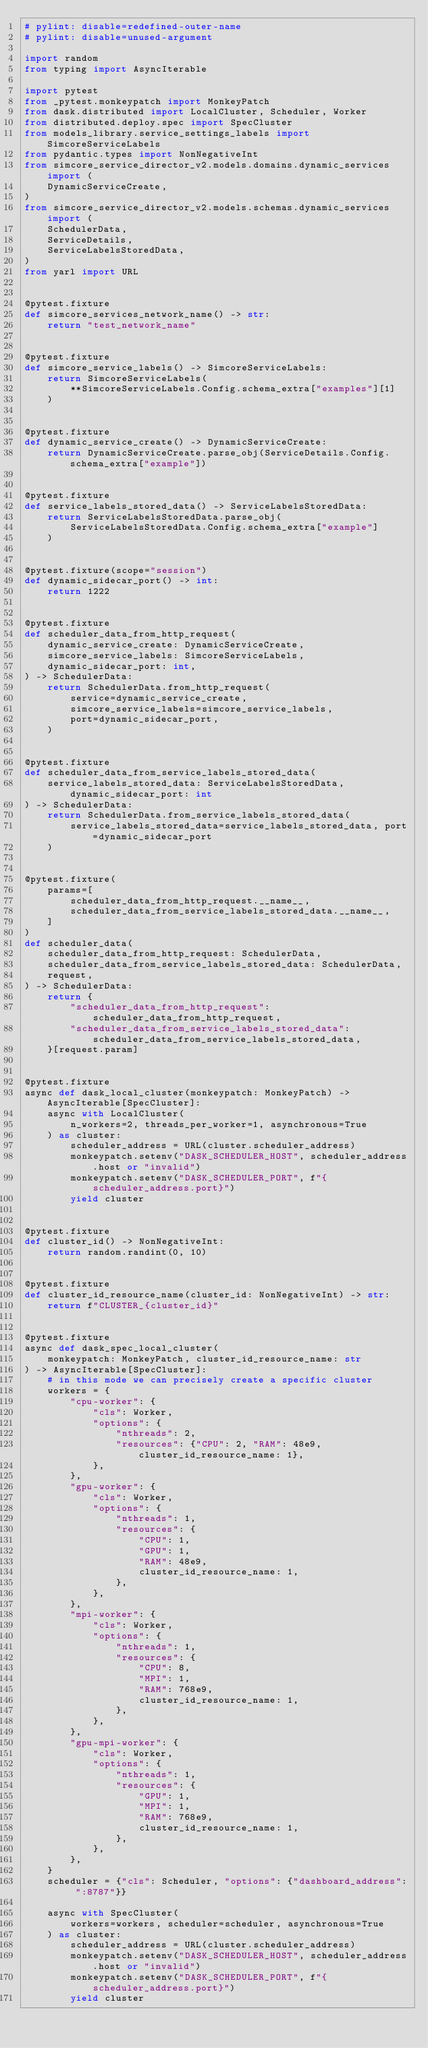<code> <loc_0><loc_0><loc_500><loc_500><_Python_># pylint: disable=redefined-outer-name
# pylint: disable=unused-argument

import random
from typing import AsyncIterable

import pytest
from _pytest.monkeypatch import MonkeyPatch
from dask.distributed import LocalCluster, Scheduler, Worker
from distributed.deploy.spec import SpecCluster
from models_library.service_settings_labels import SimcoreServiceLabels
from pydantic.types import NonNegativeInt
from simcore_service_director_v2.models.domains.dynamic_services import (
    DynamicServiceCreate,
)
from simcore_service_director_v2.models.schemas.dynamic_services import (
    SchedulerData,
    ServiceDetails,
    ServiceLabelsStoredData,
)
from yarl import URL


@pytest.fixture
def simcore_services_network_name() -> str:
    return "test_network_name"


@pytest.fixture
def simcore_service_labels() -> SimcoreServiceLabels:
    return SimcoreServiceLabels(
        **SimcoreServiceLabels.Config.schema_extra["examples"][1]
    )


@pytest.fixture
def dynamic_service_create() -> DynamicServiceCreate:
    return DynamicServiceCreate.parse_obj(ServiceDetails.Config.schema_extra["example"])


@pytest.fixture
def service_labels_stored_data() -> ServiceLabelsStoredData:
    return ServiceLabelsStoredData.parse_obj(
        ServiceLabelsStoredData.Config.schema_extra["example"]
    )


@pytest.fixture(scope="session")
def dynamic_sidecar_port() -> int:
    return 1222


@pytest.fixture
def scheduler_data_from_http_request(
    dynamic_service_create: DynamicServiceCreate,
    simcore_service_labels: SimcoreServiceLabels,
    dynamic_sidecar_port: int,
) -> SchedulerData:
    return SchedulerData.from_http_request(
        service=dynamic_service_create,
        simcore_service_labels=simcore_service_labels,
        port=dynamic_sidecar_port,
    )


@pytest.fixture
def scheduler_data_from_service_labels_stored_data(
    service_labels_stored_data: ServiceLabelsStoredData, dynamic_sidecar_port: int
) -> SchedulerData:
    return SchedulerData.from_service_labels_stored_data(
        service_labels_stored_data=service_labels_stored_data, port=dynamic_sidecar_port
    )


@pytest.fixture(
    params=[
        scheduler_data_from_http_request.__name__,
        scheduler_data_from_service_labels_stored_data.__name__,
    ]
)
def scheduler_data(
    scheduler_data_from_http_request: SchedulerData,
    scheduler_data_from_service_labels_stored_data: SchedulerData,
    request,
) -> SchedulerData:
    return {
        "scheduler_data_from_http_request": scheduler_data_from_http_request,
        "scheduler_data_from_service_labels_stored_data": scheduler_data_from_service_labels_stored_data,
    }[request.param]


@pytest.fixture
async def dask_local_cluster(monkeypatch: MonkeyPatch) -> AsyncIterable[SpecCluster]:
    async with LocalCluster(
        n_workers=2, threads_per_worker=1, asynchronous=True
    ) as cluster:
        scheduler_address = URL(cluster.scheduler_address)
        monkeypatch.setenv("DASK_SCHEDULER_HOST", scheduler_address.host or "invalid")
        monkeypatch.setenv("DASK_SCHEDULER_PORT", f"{scheduler_address.port}")
        yield cluster


@pytest.fixture
def cluster_id() -> NonNegativeInt:
    return random.randint(0, 10)


@pytest.fixture
def cluster_id_resource_name(cluster_id: NonNegativeInt) -> str:
    return f"CLUSTER_{cluster_id}"


@pytest.fixture
async def dask_spec_local_cluster(
    monkeypatch: MonkeyPatch, cluster_id_resource_name: str
) -> AsyncIterable[SpecCluster]:
    # in this mode we can precisely create a specific cluster
    workers = {
        "cpu-worker": {
            "cls": Worker,
            "options": {
                "nthreads": 2,
                "resources": {"CPU": 2, "RAM": 48e9, cluster_id_resource_name: 1},
            },
        },
        "gpu-worker": {
            "cls": Worker,
            "options": {
                "nthreads": 1,
                "resources": {
                    "CPU": 1,
                    "GPU": 1,
                    "RAM": 48e9,
                    cluster_id_resource_name: 1,
                },
            },
        },
        "mpi-worker": {
            "cls": Worker,
            "options": {
                "nthreads": 1,
                "resources": {
                    "CPU": 8,
                    "MPI": 1,
                    "RAM": 768e9,
                    cluster_id_resource_name: 1,
                },
            },
        },
        "gpu-mpi-worker": {
            "cls": Worker,
            "options": {
                "nthreads": 1,
                "resources": {
                    "GPU": 1,
                    "MPI": 1,
                    "RAM": 768e9,
                    cluster_id_resource_name: 1,
                },
            },
        },
    }
    scheduler = {"cls": Scheduler, "options": {"dashboard_address": ":8787"}}

    async with SpecCluster(
        workers=workers, scheduler=scheduler, asynchronous=True
    ) as cluster:
        scheduler_address = URL(cluster.scheduler_address)
        monkeypatch.setenv("DASK_SCHEDULER_HOST", scheduler_address.host or "invalid")
        monkeypatch.setenv("DASK_SCHEDULER_PORT", f"{scheduler_address.port}")
        yield cluster
</code> 